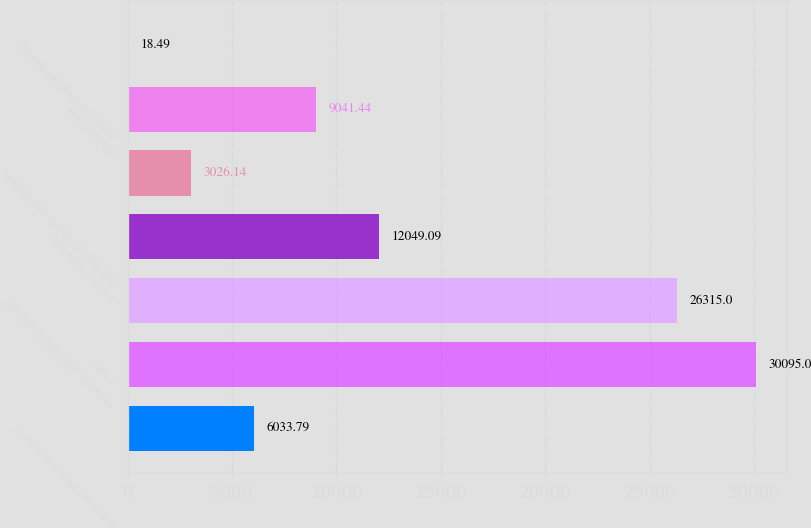Convert chart. <chart><loc_0><loc_0><loc_500><loc_500><bar_chart><fcel>in millions except per share<fcel>Sales<fcel>Operating costs and expenses<fcel>Operating income<fcel>Federal and foreign income tax<fcel>Net earnings<fcel>Diluted earnings per share<nl><fcel>6033.79<fcel>30095<fcel>26315<fcel>12049.1<fcel>3026.14<fcel>9041.44<fcel>18.49<nl></chart> 